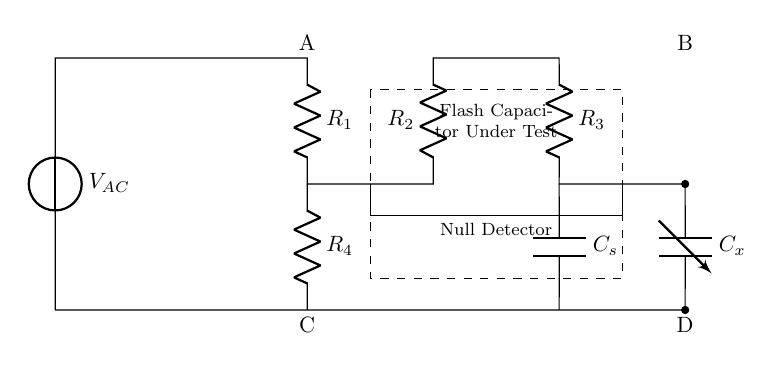What is the type of source used in this circuit? The circuit uses an AC voltage source, which is indicated by the symbol at the leftmost point of the diagram.
Answer: AC voltage source How many resistors are in the circuit? Counting the resistors labeled in the diagram, there are four resistors present, labeled as R1, R2, R3, and R4.
Answer: Four What is the purpose of the dashed rectangle in the circuit? The dashed rectangle encloses the flash capacitor under test, indicating it is the component being evaluated in this setup.
Answer: Flash capacitor under test What is connected to the null detector in the circuit? The null detector is directly connected between points corresponding to R1 and R2, indicating it measures potential difference across these components.
Answer: R1 and R2 Which component is labeled as Cx? Cx is a variable capacitor in the circuit, designed to be adjusted for the testing and calibration of the flash capacitor.
Answer: Variable capacitor What is the significance of the current flow paths in this type of bridge circuit? The current flow paths in a bridge circuit are organized so that they can create a null condition, crucial for accurate measurements of the flash capacitor's characteristics.
Answer: Create a null condition 